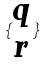<formula> <loc_0><loc_0><loc_500><loc_500>\{ \begin{matrix} q \\ r \end{matrix} \}</formula> 